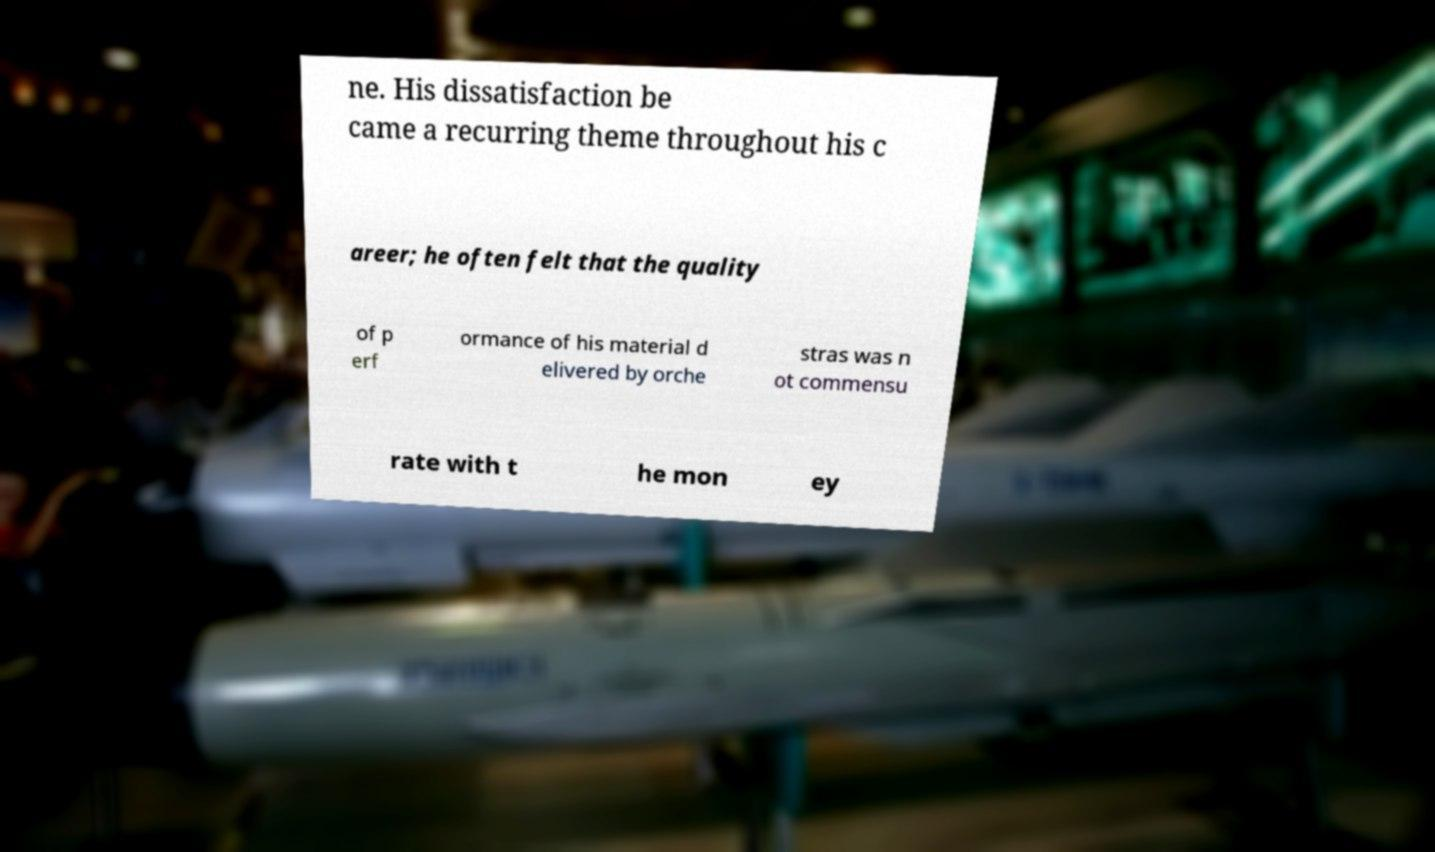Please read and relay the text visible in this image. What does it say? ne. His dissatisfaction be came a recurring theme throughout his c areer; he often felt that the quality of p erf ormance of his material d elivered by orche stras was n ot commensu rate with t he mon ey 